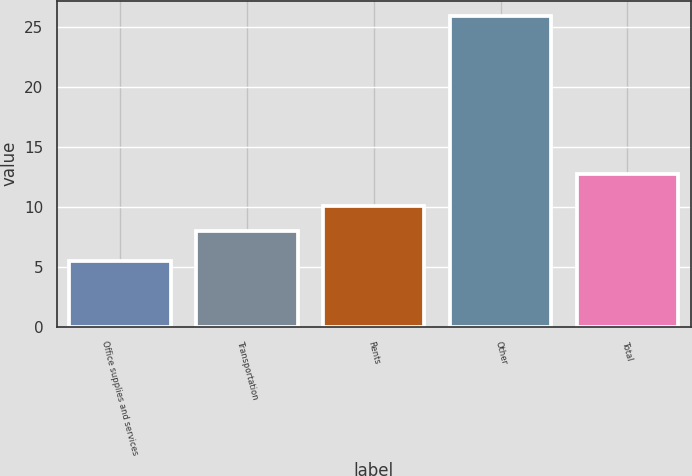<chart> <loc_0><loc_0><loc_500><loc_500><bar_chart><fcel>Office supplies and services<fcel>Transportation<fcel>Rents<fcel>Other<fcel>Total<nl><fcel>5.5<fcel>8<fcel>10.04<fcel>25.9<fcel>12.7<nl></chart> 